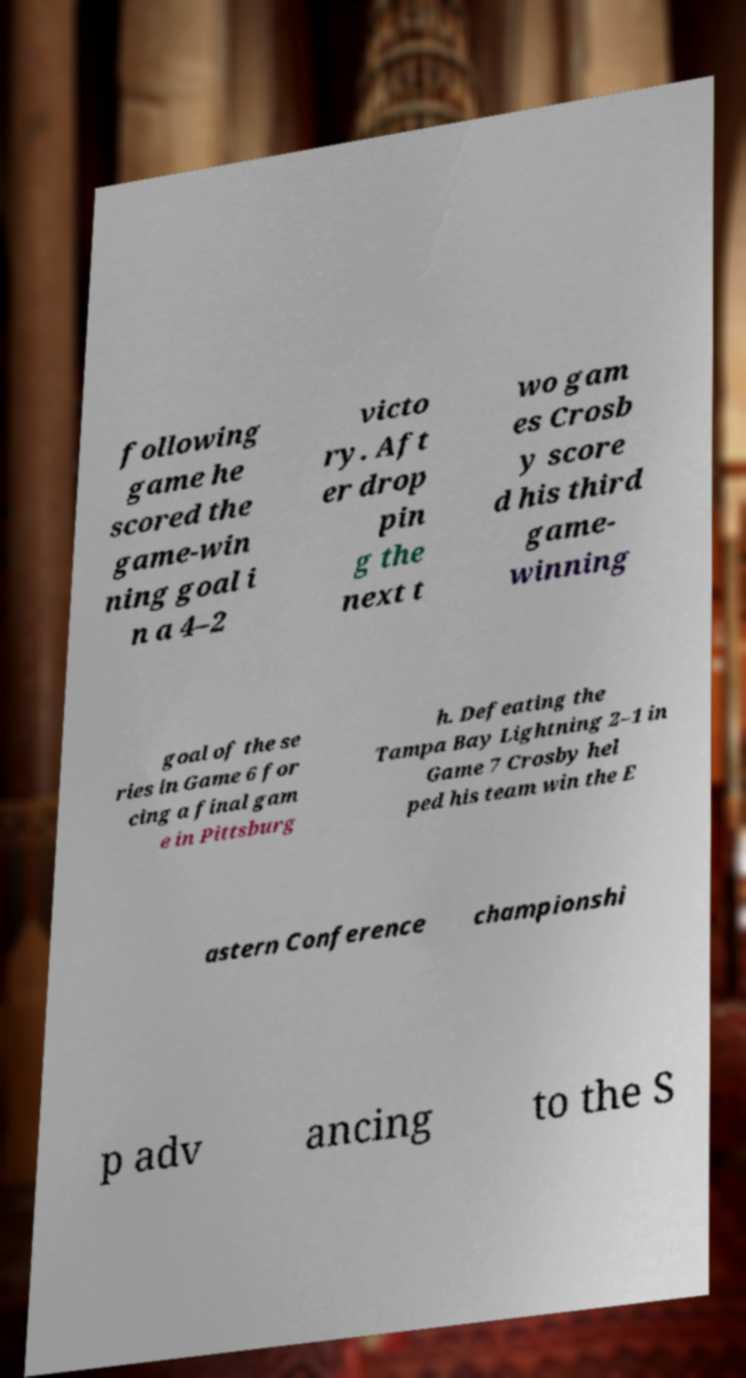Please read and relay the text visible in this image. What does it say? following game he scored the game-win ning goal i n a 4–2 victo ry. Aft er drop pin g the next t wo gam es Crosb y score d his third game- winning goal of the se ries in Game 6 for cing a final gam e in Pittsburg h. Defeating the Tampa Bay Lightning 2–1 in Game 7 Crosby hel ped his team win the E astern Conference championshi p adv ancing to the S 